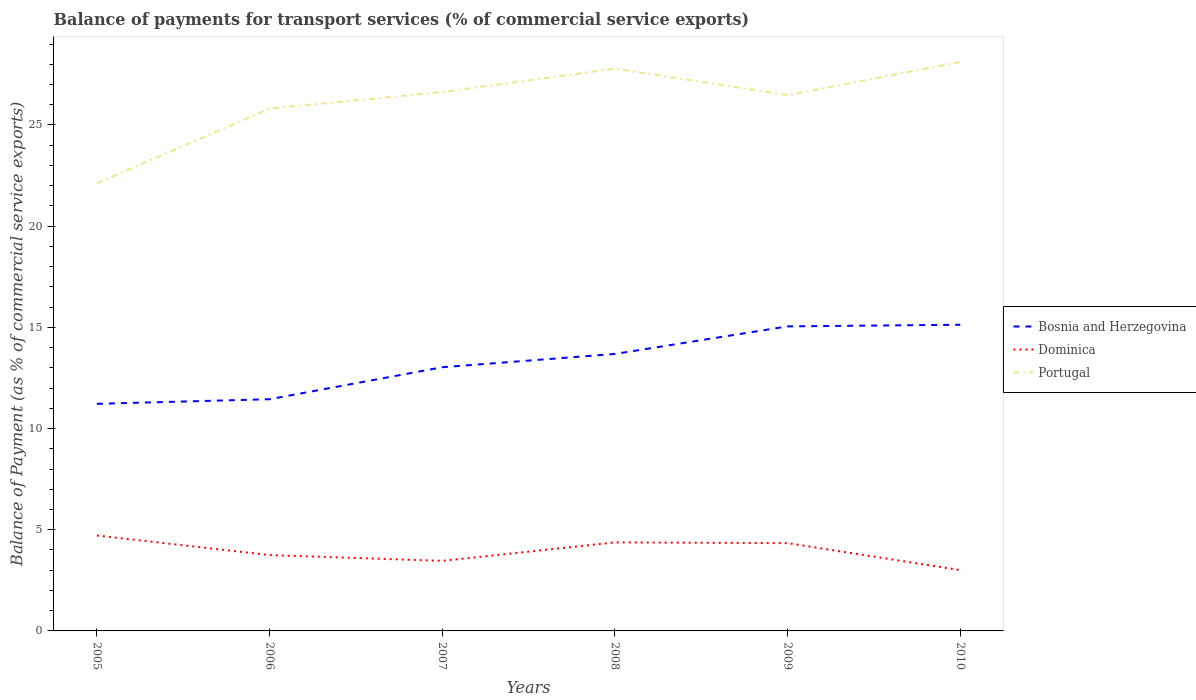Does the line corresponding to Portugal intersect with the line corresponding to Bosnia and Herzegovina?
Provide a short and direct response. No. Is the number of lines equal to the number of legend labels?
Provide a short and direct response. Yes. Across all years, what is the maximum balance of payments for transport services in Portugal?
Keep it short and to the point. 22.12. In which year was the balance of payments for transport services in Bosnia and Herzegovina maximum?
Provide a short and direct response. 2005. What is the total balance of payments for transport services in Dominica in the graph?
Make the answer very short. 1.33. What is the difference between the highest and the second highest balance of payments for transport services in Portugal?
Your answer should be very brief. 6. What is the difference between two consecutive major ticks on the Y-axis?
Offer a very short reply. 5. Are the values on the major ticks of Y-axis written in scientific E-notation?
Your response must be concise. No. Does the graph contain any zero values?
Ensure brevity in your answer.  No. Where does the legend appear in the graph?
Offer a terse response. Center right. What is the title of the graph?
Your answer should be very brief. Balance of payments for transport services (% of commercial service exports). Does "Northern Mariana Islands" appear as one of the legend labels in the graph?
Your answer should be very brief. No. What is the label or title of the Y-axis?
Provide a succinct answer. Balance of Payment (as % of commercial service exports). What is the Balance of Payment (as % of commercial service exports) in Bosnia and Herzegovina in 2005?
Give a very brief answer. 11.22. What is the Balance of Payment (as % of commercial service exports) in Dominica in 2005?
Make the answer very short. 4.71. What is the Balance of Payment (as % of commercial service exports) of Portugal in 2005?
Offer a very short reply. 22.12. What is the Balance of Payment (as % of commercial service exports) in Bosnia and Herzegovina in 2006?
Your response must be concise. 11.45. What is the Balance of Payment (as % of commercial service exports) of Dominica in 2006?
Your response must be concise. 3.75. What is the Balance of Payment (as % of commercial service exports) in Portugal in 2006?
Your answer should be very brief. 25.81. What is the Balance of Payment (as % of commercial service exports) in Bosnia and Herzegovina in 2007?
Ensure brevity in your answer.  13.03. What is the Balance of Payment (as % of commercial service exports) in Dominica in 2007?
Make the answer very short. 3.46. What is the Balance of Payment (as % of commercial service exports) in Portugal in 2007?
Provide a succinct answer. 26.63. What is the Balance of Payment (as % of commercial service exports) of Bosnia and Herzegovina in 2008?
Your answer should be compact. 13.69. What is the Balance of Payment (as % of commercial service exports) in Dominica in 2008?
Give a very brief answer. 4.37. What is the Balance of Payment (as % of commercial service exports) in Portugal in 2008?
Your answer should be compact. 27.78. What is the Balance of Payment (as % of commercial service exports) of Bosnia and Herzegovina in 2009?
Offer a very short reply. 15.05. What is the Balance of Payment (as % of commercial service exports) of Dominica in 2009?
Your answer should be compact. 4.34. What is the Balance of Payment (as % of commercial service exports) in Portugal in 2009?
Offer a very short reply. 26.48. What is the Balance of Payment (as % of commercial service exports) of Bosnia and Herzegovina in 2010?
Your answer should be compact. 15.13. What is the Balance of Payment (as % of commercial service exports) of Dominica in 2010?
Your response must be concise. 3. What is the Balance of Payment (as % of commercial service exports) in Portugal in 2010?
Keep it short and to the point. 28.11. Across all years, what is the maximum Balance of Payment (as % of commercial service exports) in Bosnia and Herzegovina?
Ensure brevity in your answer.  15.13. Across all years, what is the maximum Balance of Payment (as % of commercial service exports) of Dominica?
Offer a very short reply. 4.71. Across all years, what is the maximum Balance of Payment (as % of commercial service exports) of Portugal?
Provide a short and direct response. 28.11. Across all years, what is the minimum Balance of Payment (as % of commercial service exports) of Bosnia and Herzegovina?
Ensure brevity in your answer.  11.22. Across all years, what is the minimum Balance of Payment (as % of commercial service exports) in Dominica?
Keep it short and to the point. 3. Across all years, what is the minimum Balance of Payment (as % of commercial service exports) in Portugal?
Offer a terse response. 22.12. What is the total Balance of Payment (as % of commercial service exports) of Bosnia and Herzegovina in the graph?
Keep it short and to the point. 79.56. What is the total Balance of Payment (as % of commercial service exports) in Dominica in the graph?
Provide a succinct answer. 23.64. What is the total Balance of Payment (as % of commercial service exports) of Portugal in the graph?
Your answer should be compact. 156.93. What is the difference between the Balance of Payment (as % of commercial service exports) in Bosnia and Herzegovina in 2005 and that in 2006?
Provide a short and direct response. -0.23. What is the difference between the Balance of Payment (as % of commercial service exports) of Dominica in 2005 and that in 2006?
Your response must be concise. 0.97. What is the difference between the Balance of Payment (as % of commercial service exports) in Portugal in 2005 and that in 2006?
Your answer should be compact. -3.7. What is the difference between the Balance of Payment (as % of commercial service exports) of Bosnia and Herzegovina in 2005 and that in 2007?
Provide a short and direct response. -1.81. What is the difference between the Balance of Payment (as % of commercial service exports) of Dominica in 2005 and that in 2007?
Ensure brevity in your answer.  1.25. What is the difference between the Balance of Payment (as % of commercial service exports) of Portugal in 2005 and that in 2007?
Give a very brief answer. -4.51. What is the difference between the Balance of Payment (as % of commercial service exports) of Bosnia and Herzegovina in 2005 and that in 2008?
Keep it short and to the point. -2.47. What is the difference between the Balance of Payment (as % of commercial service exports) in Dominica in 2005 and that in 2008?
Provide a succinct answer. 0.34. What is the difference between the Balance of Payment (as % of commercial service exports) in Portugal in 2005 and that in 2008?
Ensure brevity in your answer.  -5.67. What is the difference between the Balance of Payment (as % of commercial service exports) in Bosnia and Herzegovina in 2005 and that in 2009?
Your answer should be compact. -3.83. What is the difference between the Balance of Payment (as % of commercial service exports) of Dominica in 2005 and that in 2009?
Offer a terse response. 0.38. What is the difference between the Balance of Payment (as % of commercial service exports) of Portugal in 2005 and that in 2009?
Your answer should be compact. -4.36. What is the difference between the Balance of Payment (as % of commercial service exports) in Bosnia and Herzegovina in 2005 and that in 2010?
Your response must be concise. -3.91. What is the difference between the Balance of Payment (as % of commercial service exports) of Dominica in 2005 and that in 2010?
Give a very brief answer. 1.71. What is the difference between the Balance of Payment (as % of commercial service exports) in Portugal in 2005 and that in 2010?
Offer a very short reply. -6. What is the difference between the Balance of Payment (as % of commercial service exports) of Bosnia and Herzegovina in 2006 and that in 2007?
Offer a terse response. -1.58. What is the difference between the Balance of Payment (as % of commercial service exports) of Dominica in 2006 and that in 2007?
Provide a succinct answer. 0.29. What is the difference between the Balance of Payment (as % of commercial service exports) in Portugal in 2006 and that in 2007?
Ensure brevity in your answer.  -0.82. What is the difference between the Balance of Payment (as % of commercial service exports) in Bosnia and Herzegovina in 2006 and that in 2008?
Ensure brevity in your answer.  -2.24. What is the difference between the Balance of Payment (as % of commercial service exports) in Dominica in 2006 and that in 2008?
Give a very brief answer. -0.63. What is the difference between the Balance of Payment (as % of commercial service exports) in Portugal in 2006 and that in 2008?
Provide a short and direct response. -1.97. What is the difference between the Balance of Payment (as % of commercial service exports) in Bosnia and Herzegovina in 2006 and that in 2009?
Offer a terse response. -3.6. What is the difference between the Balance of Payment (as % of commercial service exports) of Dominica in 2006 and that in 2009?
Your answer should be very brief. -0.59. What is the difference between the Balance of Payment (as % of commercial service exports) of Portugal in 2006 and that in 2009?
Offer a terse response. -0.67. What is the difference between the Balance of Payment (as % of commercial service exports) of Bosnia and Herzegovina in 2006 and that in 2010?
Your answer should be compact. -3.68. What is the difference between the Balance of Payment (as % of commercial service exports) of Dominica in 2006 and that in 2010?
Your answer should be very brief. 0.74. What is the difference between the Balance of Payment (as % of commercial service exports) in Portugal in 2006 and that in 2010?
Your response must be concise. -2.3. What is the difference between the Balance of Payment (as % of commercial service exports) of Bosnia and Herzegovina in 2007 and that in 2008?
Your answer should be very brief. -0.66. What is the difference between the Balance of Payment (as % of commercial service exports) in Dominica in 2007 and that in 2008?
Make the answer very short. -0.91. What is the difference between the Balance of Payment (as % of commercial service exports) in Portugal in 2007 and that in 2008?
Ensure brevity in your answer.  -1.16. What is the difference between the Balance of Payment (as % of commercial service exports) in Bosnia and Herzegovina in 2007 and that in 2009?
Keep it short and to the point. -2.02. What is the difference between the Balance of Payment (as % of commercial service exports) in Dominica in 2007 and that in 2009?
Your answer should be compact. -0.88. What is the difference between the Balance of Payment (as % of commercial service exports) of Portugal in 2007 and that in 2009?
Your answer should be very brief. 0.15. What is the difference between the Balance of Payment (as % of commercial service exports) in Bosnia and Herzegovina in 2007 and that in 2010?
Offer a very short reply. -2.1. What is the difference between the Balance of Payment (as % of commercial service exports) of Dominica in 2007 and that in 2010?
Your response must be concise. 0.46. What is the difference between the Balance of Payment (as % of commercial service exports) in Portugal in 2007 and that in 2010?
Provide a succinct answer. -1.49. What is the difference between the Balance of Payment (as % of commercial service exports) of Bosnia and Herzegovina in 2008 and that in 2009?
Make the answer very short. -1.36. What is the difference between the Balance of Payment (as % of commercial service exports) in Dominica in 2008 and that in 2009?
Keep it short and to the point. 0.04. What is the difference between the Balance of Payment (as % of commercial service exports) in Portugal in 2008 and that in 2009?
Make the answer very short. 1.31. What is the difference between the Balance of Payment (as % of commercial service exports) in Bosnia and Herzegovina in 2008 and that in 2010?
Make the answer very short. -1.44. What is the difference between the Balance of Payment (as % of commercial service exports) of Dominica in 2008 and that in 2010?
Your answer should be compact. 1.37. What is the difference between the Balance of Payment (as % of commercial service exports) in Portugal in 2008 and that in 2010?
Give a very brief answer. -0.33. What is the difference between the Balance of Payment (as % of commercial service exports) of Bosnia and Herzegovina in 2009 and that in 2010?
Your answer should be very brief. -0.08. What is the difference between the Balance of Payment (as % of commercial service exports) of Dominica in 2009 and that in 2010?
Make the answer very short. 1.33. What is the difference between the Balance of Payment (as % of commercial service exports) of Portugal in 2009 and that in 2010?
Your answer should be very brief. -1.64. What is the difference between the Balance of Payment (as % of commercial service exports) of Bosnia and Herzegovina in 2005 and the Balance of Payment (as % of commercial service exports) of Dominica in 2006?
Keep it short and to the point. 7.47. What is the difference between the Balance of Payment (as % of commercial service exports) in Bosnia and Herzegovina in 2005 and the Balance of Payment (as % of commercial service exports) in Portugal in 2006?
Give a very brief answer. -14.59. What is the difference between the Balance of Payment (as % of commercial service exports) in Dominica in 2005 and the Balance of Payment (as % of commercial service exports) in Portugal in 2006?
Offer a terse response. -21.1. What is the difference between the Balance of Payment (as % of commercial service exports) in Bosnia and Herzegovina in 2005 and the Balance of Payment (as % of commercial service exports) in Dominica in 2007?
Your answer should be very brief. 7.76. What is the difference between the Balance of Payment (as % of commercial service exports) of Bosnia and Herzegovina in 2005 and the Balance of Payment (as % of commercial service exports) of Portugal in 2007?
Make the answer very short. -15.41. What is the difference between the Balance of Payment (as % of commercial service exports) of Dominica in 2005 and the Balance of Payment (as % of commercial service exports) of Portugal in 2007?
Give a very brief answer. -21.91. What is the difference between the Balance of Payment (as % of commercial service exports) in Bosnia and Herzegovina in 2005 and the Balance of Payment (as % of commercial service exports) in Dominica in 2008?
Provide a short and direct response. 6.85. What is the difference between the Balance of Payment (as % of commercial service exports) of Bosnia and Herzegovina in 2005 and the Balance of Payment (as % of commercial service exports) of Portugal in 2008?
Make the answer very short. -16.56. What is the difference between the Balance of Payment (as % of commercial service exports) in Dominica in 2005 and the Balance of Payment (as % of commercial service exports) in Portugal in 2008?
Give a very brief answer. -23.07. What is the difference between the Balance of Payment (as % of commercial service exports) in Bosnia and Herzegovina in 2005 and the Balance of Payment (as % of commercial service exports) in Dominica in 2009?
Ensure brevity in your answer.  6.88. What is the difference between the Balance of Payment (as % of commercial service exports) of Bosnia and Herzegovina in 2005 and the Balance of Payment (as % of commercial service exports) of Portugal in 2009?
Make the answer very short. -15.26. What is the difference between the Balance of Payment (as % of commercial service exports) of Dominica in 2005 and the Balance of Payment (as % of commercial service exports) of Portugal in 2009?
Provide a succinct answer. -21.76. What is the difference between the Balance of Payment (as % of commercial service exports) in Bosnia and Herzegovina in 2005 and the Balance of Payment (as % of commercial service exports) in Dominica in 2010?
Give a very brief answer. 8.22. What is the difference between the Balance of Payment (as % of commercial service exports) of Bosnia and Herzegovina in 2005 and the Balance of Payment (as % of commercial service exports) of Portugal in 2010?
Provide a short and direct response. -16.89. What is the difference between the Balance of Payment (as % of commercial service exports) of Dominica in 2005 and the Balance of Payment (as % of commercial service exports) of Portugal in 2010?
Your response must be concise. -23.4. What is the difference between the Balance of Payment (as % of commercial service exports) in Bosnia and Herzegovina in 2006 and the Balance of Payment (as % of commercial service exports) in Dominica in 2007?
Make the answer very short. 7.99. What is the difference between the Balance of Payment (as % of commercial service exports) of Bosnia and Herzegovina in 2006 and the Balance of Payment (as % of commercial service exports) of Portugal in 2007?
Provide a succinct answer. -15.18. What is the difference between the Balance of Payment (as % of commercial service exports) in Dominica in 2006 and the Balance of Payment (as % of commercial service exports) in Portugal in 2007?
Keep it short and to the point. -22.88. What is the difference between the Balance of Payment (as % of commercial service exports) of Bosnia and Herzegovina in 2006 and the Balance of Payment (as % of commercial service exports) of Dominica in 2008?
Your answer should be very brief. 7.07. What is the difference between the Balance of Payment (as % of commercial service exports) of Bosnia and Herzegovina in 2006 and the Balance of Payment (as % of commercial service exports) of Portugal in 2008?
Offer a very short reply. -16.33. What is the difference between the Balance of Payment (as % of commercial service exports) in Dominica in 2006 and the Balance of Payment (as % of commercial service exports) in Portugal in 2008?
Provide a succinct answer. -24.04. What is the difference between the Balance of Payment (as % of commercial service exports) in Bosnia and Herzegovina in 2006 and the Balance of Payment (as % of commercial service exports) in Dominica in 2009?
Give a very brief answer. 7.11. What is the difference between the Balance of Payment (as % of commercial service exports) of Bosnia and Herzegovina in 2006 and the Balance of Payment (as % of commercial service exports) of Portugal in 2009?
Keep it short and to the point. -15.03. What is the difference between the Balance of Payment (as % of commercial service exports) of Dominica in 2006 and the Balance of Payment (as % of commercial service exports) of Portugal in 2009?
Your answer should be very brief. -22.73. What is the difference between the Balance of Payment (as % of commercial service exports) of Bosnia and Herzegovina in 2006 and the Balance of Payment (as % of commercial service exports) of Dominica in 2010?
Offer a terse response. 8.44. What is the difference between the Balance of Payment (as % of commercial service exports) of Bosnia and Herzegovina in 2006 and the Balance of Payment (as % of commercial service exports) of Portugal in 2010?
Give a very brief answer. -16.66. What is the difference between the Balance of Payment (as % of commercial service exports) in Dominica in 2006 and the Balance of Payment (as % of commercial service exports) in Portugal in 2010?
Offer a very short reply. -24.37. What is the difference between the Balance of Payment (as % of commercial service exports) in Bosnia and Herzegovina in 2007 and the Balance of Payment (as % of commercial service exports) in Dominica in 2008?
Keep it short and to the point. 8.65. What is the difference between the Balance of Payment (as % of commercial service exports) of Bosnia and Herzegovina in 2007 and the Balance of Payment (as % of commercial service exports) of Portugal in 2008?
Your answer should be compact. -14.75. What is the difference between the Balance of Payment (as % of commercial service exports) in Dominica in 2007 and the Balance of Payment (as % of commercial service exports) in Portugal in 2008?
Give a very brief answer. -24.32. What is the difference between the Balance of Payment (as % of commercial service exports) of Bosnia and Herzegovina in 2007 and the Balance of Payment (as % of commercial service exports) of Dominica in 2009?
Your answer should be compact. 8.69. What is the difference between the Balance of Payment (as % of commercial service exports) of Bosnia and Herzegovina in 2007 and the Balance of Payment (as % of commercial service exports) of Portugal in 2009?
Your response must be concise. -13.45. What is the difference between the Balance of Payment (as % of commercial service exports) of Dominica in 2007 and the Balance of Payment (as % of commercial service exports) of Portugal in 2009?
Offer a terse response. -23.02. What is the difference between the Balance of Payment (as % of commercial service exports) in Bosnia and Herzegovina in 2007 and the Balance of Payment (as % of commercial service exports) in Dominica in 2010?
Give a very brief answer. 10.03. What is the difference between the Balance of Payment (as % of commercial service exports) of Bosnia and Herzegovina in 2007 and the Balance of Payment (as % of commercial service exports) of Portugal in 2010?
Offer a terse response. -15.08. What is the difference between the Balance of Payment (as % of commercial service exports) in Dominica in 2007 and the Balance of Payment (as % of commercial service exports) in Portugal in 2010?
Offer a terse response. -24.65. What is the difference between the Balance of Payment (as % of commercial service exports) of Bosnia and Herzegovina in 2008 and the Balance of Payment (as % of commercial service exports) of Dominica in 2009?
Provide a succinct answer. 9.35. What is the difference between the Balance of Payment (as % of commercial service exports) in Bosnia and Herzegovina in 2008 and the Balance of Payment (as % of commercial service exports) in Portugal in 2009?
Your answer should be very brief. -12.79. What is the difference between the Balance of Payment (as % of commercial service exports) in Dominica in 2008 and the Balance of Payment (as % of commercial service exports) in Portugal in 2009?
Offer a terse response. -22.1. What is the difference between the Balance of Payment (as % of commercial service exports) of Bosnia and Herzegovina in 2008 and the Balance of Payment (as % of commercial service exports) of Dominica in 2010?
Provide a short and direct response. 10.68. What is the difference between the Balance of Payment (as % of commercial service exports) of Bosnia and Herzegovina in 2008 and the Balance of Payment (as % of commercial service exports) of Portugal in 2010?
Offer a very short reply. -14.43. What is the difference between the Balance of Payment (as % of commercial service exports) of Dominica in 2008 and the Balance of Payment (as % of commercial service exports) of Portugal in 2010?
Provide a short and direct response. -23.74. What is the difference between the Balance of Payment (as % of commercial service exports) of Bosnia and Herzegovina in 2009 and the Balance of Payment (as % of commercial service exports) of Dominica in 2010?
Give a very brief answer. 12.04. What is the difference between the Balance of Payment (as % of commercial service exports) of Bosnia and Herzegovina in 2009 and the Balance of Payment (as % of commercial service exports) of Portugal in 2010?
Make the answer very short. -13.06. What is the difference between the Balance of Payment (as % of commercial service exports) in Dominica in 2009 and the Balance of Payment (as % of commercial service exports) in Portugal in 2010?
Your answer should be compact. -23.78. What is the average Balance of Payment (as % of commercial service exports) of Bosnia and Herzegovina per year?
Ensure brevity in your answer.  13.26. What is the average Balance of Payment (as % of commercial service exports) of Dominica per year?
Offer a very short reply. 3.94. What is the average Balance of Payment (as % of commercial service exports) in Portugal per year?
Your answer should be compact. 26.16. In the year 2005, what is the difference between the Balance of Payment (as % of commercial service exports) in Bosnia and Herzegovina and Balance of Payment (as % of commercial service exports) in Dominica?
Your response must be concise. 6.51. In the year 2005, what is the difference between the Balance of Payment (as % of commercial service exports) of Bosnia and Herzegovina and Balance of Payment (as % of commercial service exports) of Portugal?
Provide a short and direct response. -10.9. In the year 2005, what is the difference between the Balance of Payment (as % of commercial service exports) in Dominica and Balance of Payment (as % of commercial service exports) in Portugal?
Ensure brevity in your answer.  -17.4. In the year 2006, what is the difference between the Balance of Payment (as % of commercial service exports) of Bosnia and Herzegovina and Balance of Payment (as % of commercial service exports) of Dominica?
Provide a succinct answer. 7.7. In the year 2006, what is the difference between the Balance of Payment (as % of commercial service exports) of Bosnia and Herzegovina and Balance of Payment (as % of commercial service exports) of Portugal?
Give a very brief answer. -14.36. In the year 2006, what is the difference between the Balance of Payment (as % of commercial service exports) in Dominica and Balance of Payment (as % of commercial service exports) in Portugal?
Offer a very short reply. -22.06. In the year 2007, what is the difference between the Balance of Payment (as % of commercial service exports) of Bosnia and Herzegovina and Balance of Payment (as % of commercial service exports) of Dominica?
Your response must be concise. 9.57. In the year 2007, what is the difference between the Balance of Payment (as % of commercial service exports) in Bosnia and Herzegovina and Balance of Payment (as % of commercial service exports) in Portugal?
Provide a short and direct response. -13.6. In the year 2007, what is the difference between the Balance of Payment (as % of commercial service exports) in Dominica and Balance of Payment (as % of commercial service exports) in Portugal?
Your response must be concise. -23.17. In the year 2008, what is the difference between the Balance of Payment (as % of commercial service exports) of Bosnia and Herzegovina and Balance of Payment (as % of commercial service exports) of Dominica?
Keep it short and to the point. 9.31. In the year 2008, what is the difference between the Balance of Payment (as % of commercial service exports) in Bosnia and Herzegovina and Balance of Payment (as % of commercial service exports) in Portugal?
Your answer should be compact. -14.1. In the year 2008, what is the difference between the Balance of Payment (as % of commercial service exports) in Dominica and Balance of Payment (as % of commercial service exports) in Portugal?
Your answer should be very brief. -23.41. In the year 2009, what is the difference between the Balance of Payment (as % of commercial service exports) in Bosnia and Herzegovina and Balance of Payment (as % of commercial service exports) in Dominica?
Keep it short and to the point. 10.71. In the year 2009, what is the difference between the Balance of Payment (as % of commercial service exports) in Bosnia and Herzegovina and Balance of Payment (as % of commercial service exports) in Portugal?
Provide a short and direct response. -11.43. In the year 2009, what is the difference between the Balance of Payment (as % of commercial service exports) of Dominica and Balance of Payment (as % of commercial service exports) of Portugal?
Offer a terse response. -22.14. In the year 2010, what is the difference between the Balance of Payment (as % of commercial service exports) in Bosnia and Herzegovina and Balance of Payment (as % of commercial service exports) in Dominica?
Your response must be concise. 12.13. In the year 2010, what is the difference between the Balance of Payment (as % of commercial service exports) in Bosnia and Herzegovina and Balance of Payment (as % of commercial service exports) in Portugal?
Your answer should be very brief. -12.98. In the year 2010, what is the difference between the Balance of Payment (as % of commercial service exports) in Dominica and Balance of Payment (as % of commercial service exports) in Portugal?
Offer a terse response. -25.11. What is the ratio of the Balance of Payment (as % of commercial service exports) in Bosnia and Herzegovina in 2005 to that in 2006?
Offer a very short reply. 0.98. What is the ratio of the Balance of Payment (as % of commercial service exports) in Dominica in 2005 to that in 2006?
Your response must be concise. 1.26. What is the ratio of the Balance of Payment (as % of commercial service exports) of Portugal in 2005 to that in 2006?
Ensure brevity in your answer.  0.86. What is the ratio of the Balance of Payment (as % of commercial service exports) in Bosnia and Herzegovina in 2005 to that in 2007?
Keep it short and to the point. 0.86. What is the ratio of the Balance of Payment (as % of commercial service exports) in Dominica in 2005 to that in 2007?
Keep it short and to the point. 1.36. What is the ratio of the Balance of Payment (as % of commercial service exports) in Portugal in 2005 to that in 2007?
Your response must be concise. 0.83. What is the ratio of the Balance of Payment (as % of commercial service exports) in Bosnia and Herzegovina in 2005 to that in 2008?
Provide a short and direct response. 0.82. What is the ratio of the Balance of Payment (as % of commercial service exports) of Dominica in 2005 to that in 2008?
Your answer should be very brief. 1.08. What is the ratio of the Balance of Payment (as % of commercial service exports) in Portugal in 2005 to that in 2008?
Give a very brief answer. 0.8. What is the ratio of the Balance of Payment (as % of commercial service exports) in Bosnia and Herzegovina in 2005 to that in 2009?
Offer a very short reply. 0.75. What is the ratio of the Balance of Payment (as % of commercial service exports) of Dominica in 2005 to that in 2009?
Your answer should be compact. 1.09. What is the ratio of the Balance of Payment (as % of commercial service exports) in Portugal in 2005 to that in 2009?
Provide a succinct answer. 0.84. What is the ratio of the Balance of Payment (as % of commercial service exports) of Bosnia and Herzegovina in 2005 to that in 2010?
Provide a succinct answer. 0.74. What is the ratio of the Balance of Payment (as % of commercial service exports) of Dominica in 2005 to that in 2010?
Your response must be concise. 1.57. What is the ratio of the Balance of Payment (as % of commercial service exports) in Portugal in 2005 to that in 2010?
Your answer should be compact. 0.79. What is the ratio of the Balance of Payment (as % of commercial service exports) of Bosnia and Herzegovina in 2006 to that in 2007?
Make the answer very short. 0.88. What is the ratio of the Balance of Payment (as % of commercial service exports) of Dominica in 2006 to that in 2007?
Your response must be concise. 1.08. What is the ratio of the Balance of Payment (as % of commercial service exports) of Portugal in 2006 to that in 2007?
Your answer should be very brief. 0.97. What is the ratio of the Balance of Payment (as % of commercial service exports) in Bosnia and Herzegovina in 2006 to that in 2008?
Your answer should be compact. 0.84. What is the ratio of the Balance of Payment (as % of commercial service exports) in Dominica in 2006 to that in 2008?
Give a very brief answer. 0.86. What is the ratio of the Balance of Payment (as % of commercial service exports) in Portugal in 2006 to that in 2008?
Offer a very short reply. 0.93. What is the ratio of the Balance of Payment (as % of commercial service exports) of Bosnia and Herzegovina in 2006 to that in 2009?
Offer a terse response. 0.76. What is the ratio of the Balance of Payment (as % of commercial service exports) in Dominica in 2006 to that in 2009?
Your answer should be compact. 0.86. What is the ratio of the Balance of Payment (as % of commercial service exports) of Portugal in 2006 to that in 2009?
Give a very brief answer. 0.97. What is the ratio of the Balance of Payment (as % of commercial service exports) in Bosnia and Herzegovina in 2006 to that in 2010?
Offer a very short reply. 0.76. What is the ratio of the Balance of Payment (as % of commercial service exports) in Dominica in 2006 to that in 2010?
Give a very brief answer. 1.25. What is the ratio of the Balance of Payment (as % of commercial service exports) of Portugal in 2006 to that in 2010?
Give a very brief answer. 0.92. What is the ratio of the Balance of Payment (as % of commercial service exports) of Dominica in 2007 to that in 2008?
Provide a succinct answer. 0.79. What is the ratio of the Balance of Payment (as % of commercial service exports) in Portugal in 2007 to that in 2008?
Ensure brevity in your answer.  0.96. What is the ratio of the Balance of Payment (as % of commercial service exports) of Bosnia and Herzegovina in 2007 to that in 2009?
Ensure brevity in your answer.  0.87. What is the ratio of the Balance of Payment (as % of commercial service exports) of Dominica in 2007 to that in 2009?
Your answer should be very brief. 0.8. What is the ratio of the Balance of Payment (as % of commercial service exports) in Portugal in 2007 to that in 2009?
Give a very brief answer. 1.01. What is the ratio of the Balance of Payment (as % of commercial service exports) in Bosnia and Herzegovina in 2007 to that in 2010?
Offer a terse response. 0.86. What is the ratio of the Balance of Payment (as % of commercial service exports) of Dominica in 2007 to that in 2010?
Ensure brevity in your answer.  1.15. What is the ratio of the Balance of Payment (as % of commercial service exports) of Portugal in 2007 to that in 2010?
Provide a short and direct response. 0.95. What is the ratio of the Balance of Payment (as % of commercial service exports) of Bosnia and Herzegovina in 2008 to that in 2009?
Provide a succinct answer. 0.91. What is the ratio of the Balance of Payment (as % of commercial service exports) of Dominica in 2008 to that in 2009?
Offer a very short reply. 1.01. What is the ratio of the Balance of Payment (as % of commercial service exports) in Portugal in 2008 to that in 2009?
Ensure brevity in your answer.  1.05. What is the ratio of the Balance of Payment (as % of commercial service exports) in Bosnia and Herzegovina in 2008 to that in 2010?
Make the answer very short. 0.9. What is the ratio of the Balance of Payment (as % of commercial service exports) of Dominica in 2008 to that in 2010?
Your answer should be compact. 1.46. What is the ratio of the Balance of Payment (as % of commercial service exports) in Portugal in 2008 to that in 2010?
Your answer should be very brief. 0.99. What is the ratio of the Balance of Payment (as % of commercial service exports) in Bosnia and Herzegovina in 2009 to that in 2010?
Ensure brevity in your answer.  0.99. What is the ratio of the Balance of Payment (as % of commercial service exports) in Dominica in 2009 to that in 2010?
Provide a succinct answer. 1.44. What is the ratio of the Balance of Payment (as % of commercial service exports) in Portugal in 2009 to that in 2010?
Ensure brevity in your answer.  0.94. What is the difference between the highest and the second highest Balance of Payment (as % of commercial service exports) in Bosnia and Herzegovina?
Your answer should be very brief. 0.08. What is the difference between the highest and the second highest Balance of Payment (as % of commercial service exports) in Dominica?
Your answer should be very brief. 0.34. What is the difference between the highest and the second highest Balance of Payment (as % of commercial service exports) of Portugal?
Your answer should be compact. 0.33. What is the difference between the highest and the lowest Balance of Payment (as % of commercial service exports) in Bosnia and Herzegovina?
Offer a terse response. 3.91. What is the difference between the highest and the lowest Balance of Payment (as % of commercial service exports) of Dominica?
Make the answer very short. 1.71. What is the difference between the highest and the lowest Balance of Payment (as % of commercial service exports) of Portugal?
Provide a succinct answer. 6. 